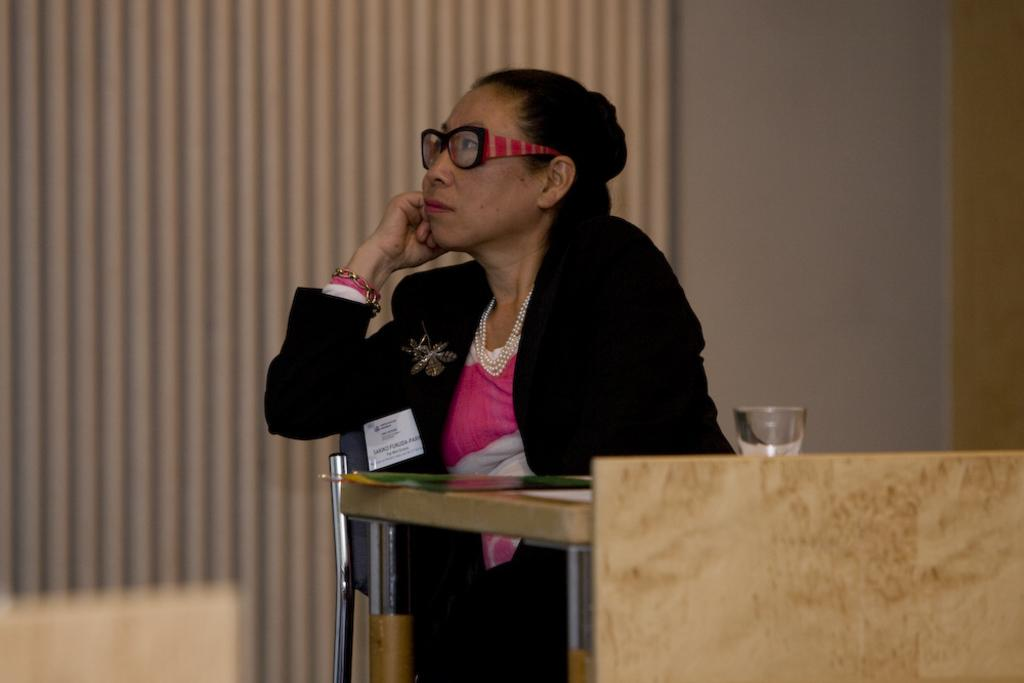What is the woman in the image doing? The woman is sitting on a chair in the image. What accessories is the woman wearing? The woman is wearing a necklace and glasses (specs) in the image. What type of clothing is the woman wearing? The woman is wearing a blazer in the image. What can be seen on the table in the image? There is a glass on the table in the image. How many men are present in the image? There are no men present in the image; it features a woman. What is the size and shape of the woman's brain in the image? There is no information about the woman's brain in the image, as it is not visible. 